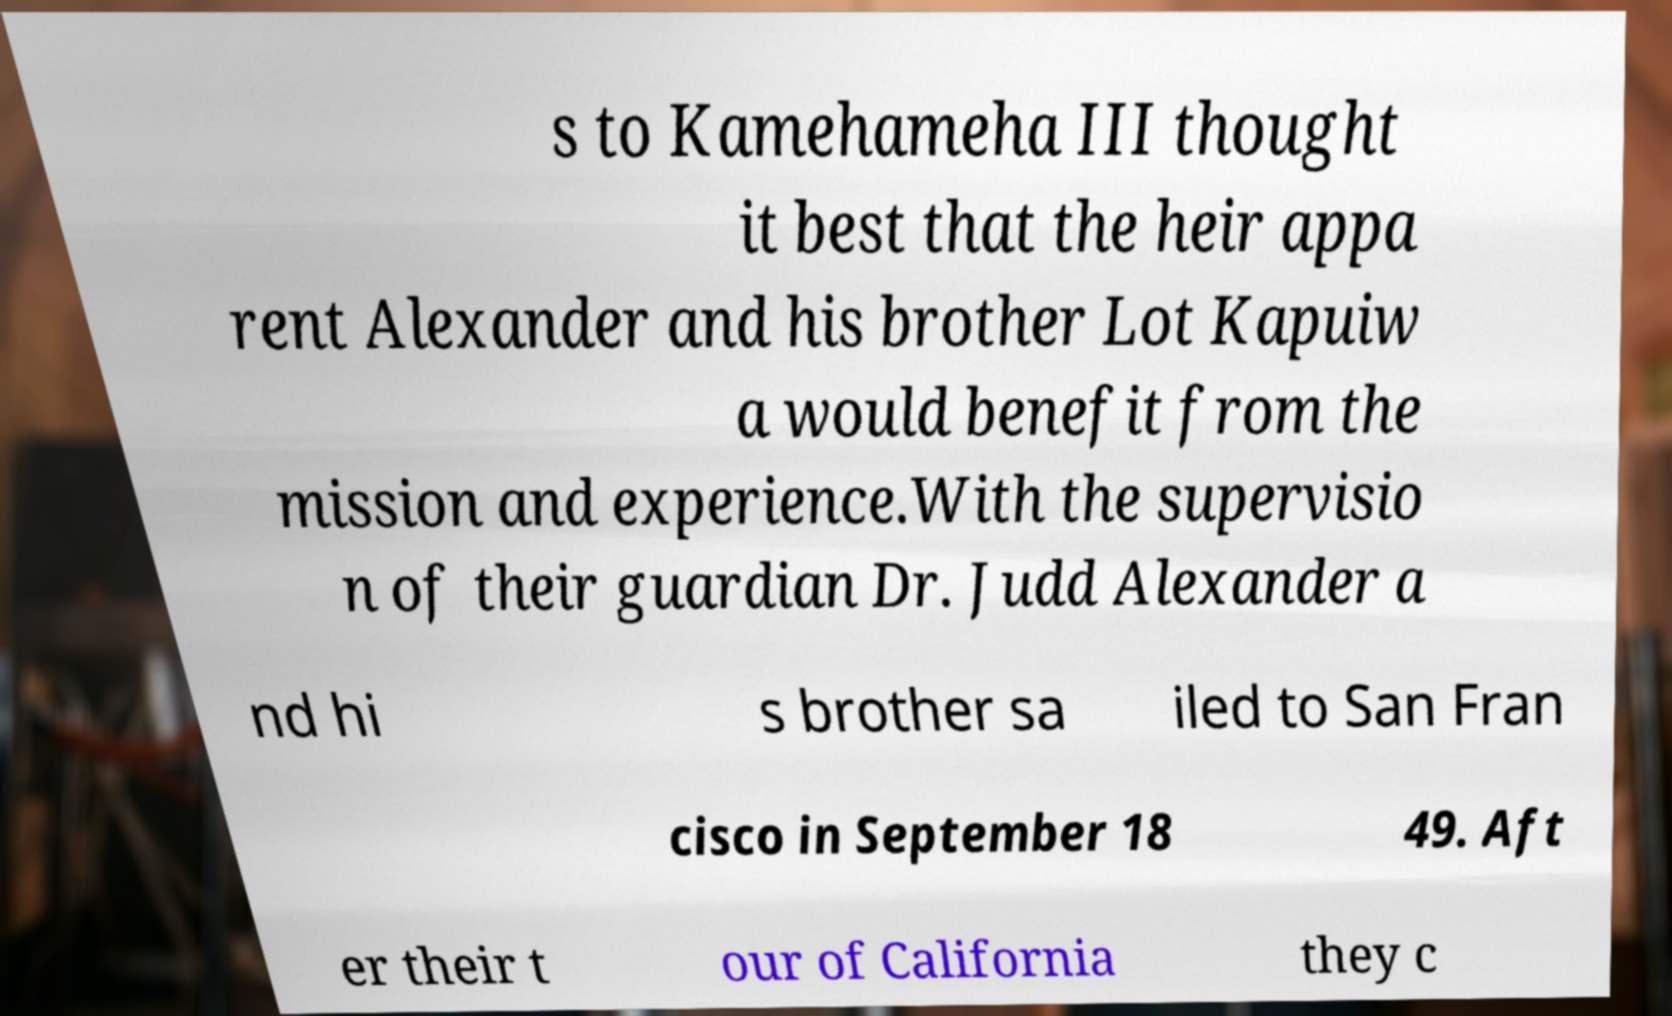Could you extract and type out the text from this image? s to Kamehameha III thought it best that the heir appa rent Alexander and his brother Lot Kapuiw a would benefit from the mission and experience.With the supervisio n of their guardian Dr. Judd Alexander a nd hi s brother sa iled to San Fran cisco in September 18 49. Aft er their t our of California they c 